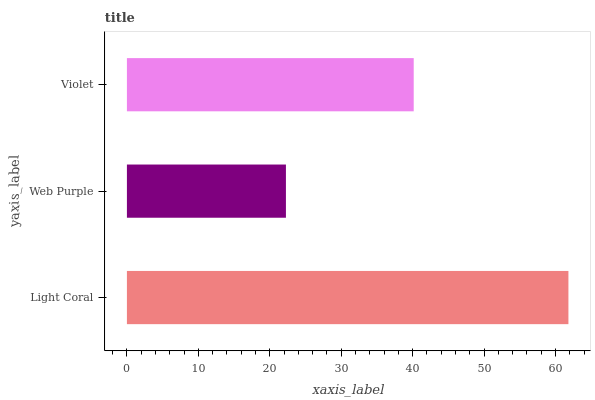Is Web Purple the minimum?
Answer yes or no. Yes. Is Light Coral the maximum?
Answer yes or no. Yes. Is Violet the minimum?
Answer yes or no. No. Is Violet the maximum?
Answer yes or no. No. Is Violet greater than Web Purple?
Answer yes or no. Yes. Is Web Purple less than Violet?
Answer yes or no. Yes. Is Web Purple greater than Violet?
Answer yes or no. No. Is Violet less than Web Purple?
Answer yes or no. No. Is Violet the high median?
Answer yes or no. Yes. Is Violet the low median?
Answer yes or no. Yes. Is Light Coral the high median?
Answer yes or no. No. Is Light Coral the low median?
Answer yes or no. No. 